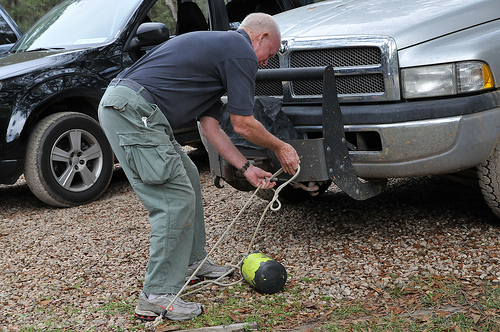Who is wearing the belt? The man in the gray trousers is the one wearing a black belt, which ensures a snug fit for his active endeavors. 